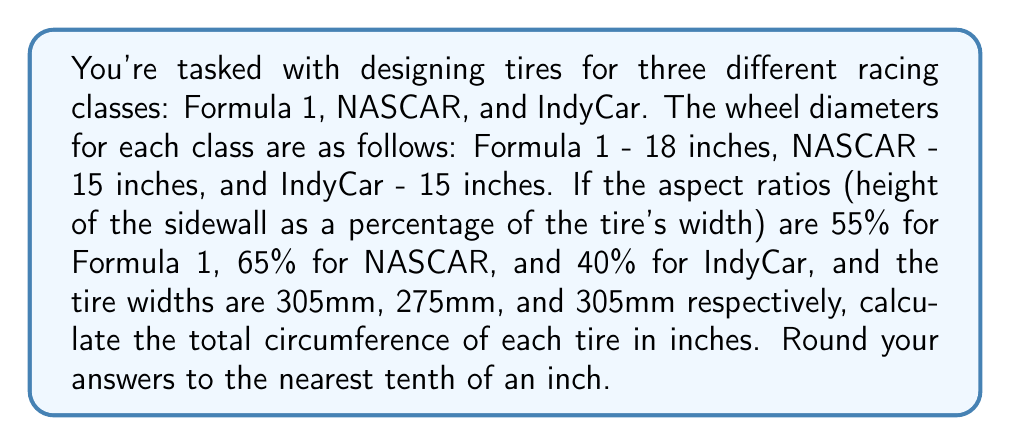Provide a solution to this math problem. Let's approach this step-by-step for each racing class:

1. Formula 1:
   - Wheel diameter: 18 inches
   - Aspect ratio: 55%
   - Tire width: 305mm

   First, convert tire width to inches: $305mm \times \frac{1 inch}{25.4mm} = 12 inches$
   
   Sidewall height: $12 inches \times 0.55 = 6.6 inches$
   
   Total tire diameter: $18 + (2 \times 6.6) = 31.2 inches$
   
   Circumference: $C = \pi d = \pi \times 31.2 = 98.0 inches$

2. NASCAR:
   - Wheel diameter: 15 inches
   - Aspect ratio: 65%
   - Tire width: 275mm

   Convert tire width: $275mm \times \frac{1 inch}{25.4mm} = 10.8 inches$
   
   Sidewall height: $10.8 inches \times 0.65 = 7.0 inches$
   
   Total tire diameter: $15 + (2 \times 7.0) = 29.0 inches$
   
   Circumference: $C = \pi d = \pi \times 29.0 = 91.1 inches$

3. IndyCar:
   - Wheel diameter: 15 inches
   - Aspect ratio: 40%
   - Tire width: 305mm

   Convert tire width: $305mm \times \frac{1 inch}{25.4mm} = 12 inches$
   
   Sidewall height: $12 inches \times 0.40 = 4.8 inches$
   
   Total tire diameter: $15 + (2 \times 4.8) = 24.6 inches$
   
   Circumference: $C = \pi d = \pi \times 24.6 = 77.3 inches$
Answer: Formula 1: 98.0 inches, NASCAR: 91.1 inches, IndyCar: 77.3 inches 